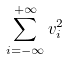<formula> <loc_0><loc_0><loc_500><loc_500>\sum _ { i = - \infty } ^ { + \infty } v _ { i } ^ { 2 }</formula> 